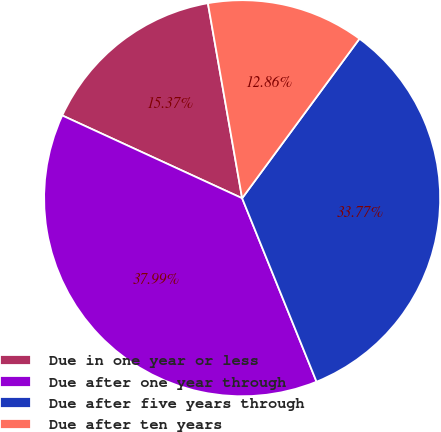Convert chart to OTSL. <chart><loc_0><loc_0><loc_500><loc_500><pie_chart><fcel>Due in one year or less<fcel>Due after one year through<fcel>Due after five years through<fcel>Due after ten years<nl><fcel>15.37%<fcel>37.99%<fcel>33.77%<fcel>12.86%<nl></chart> 